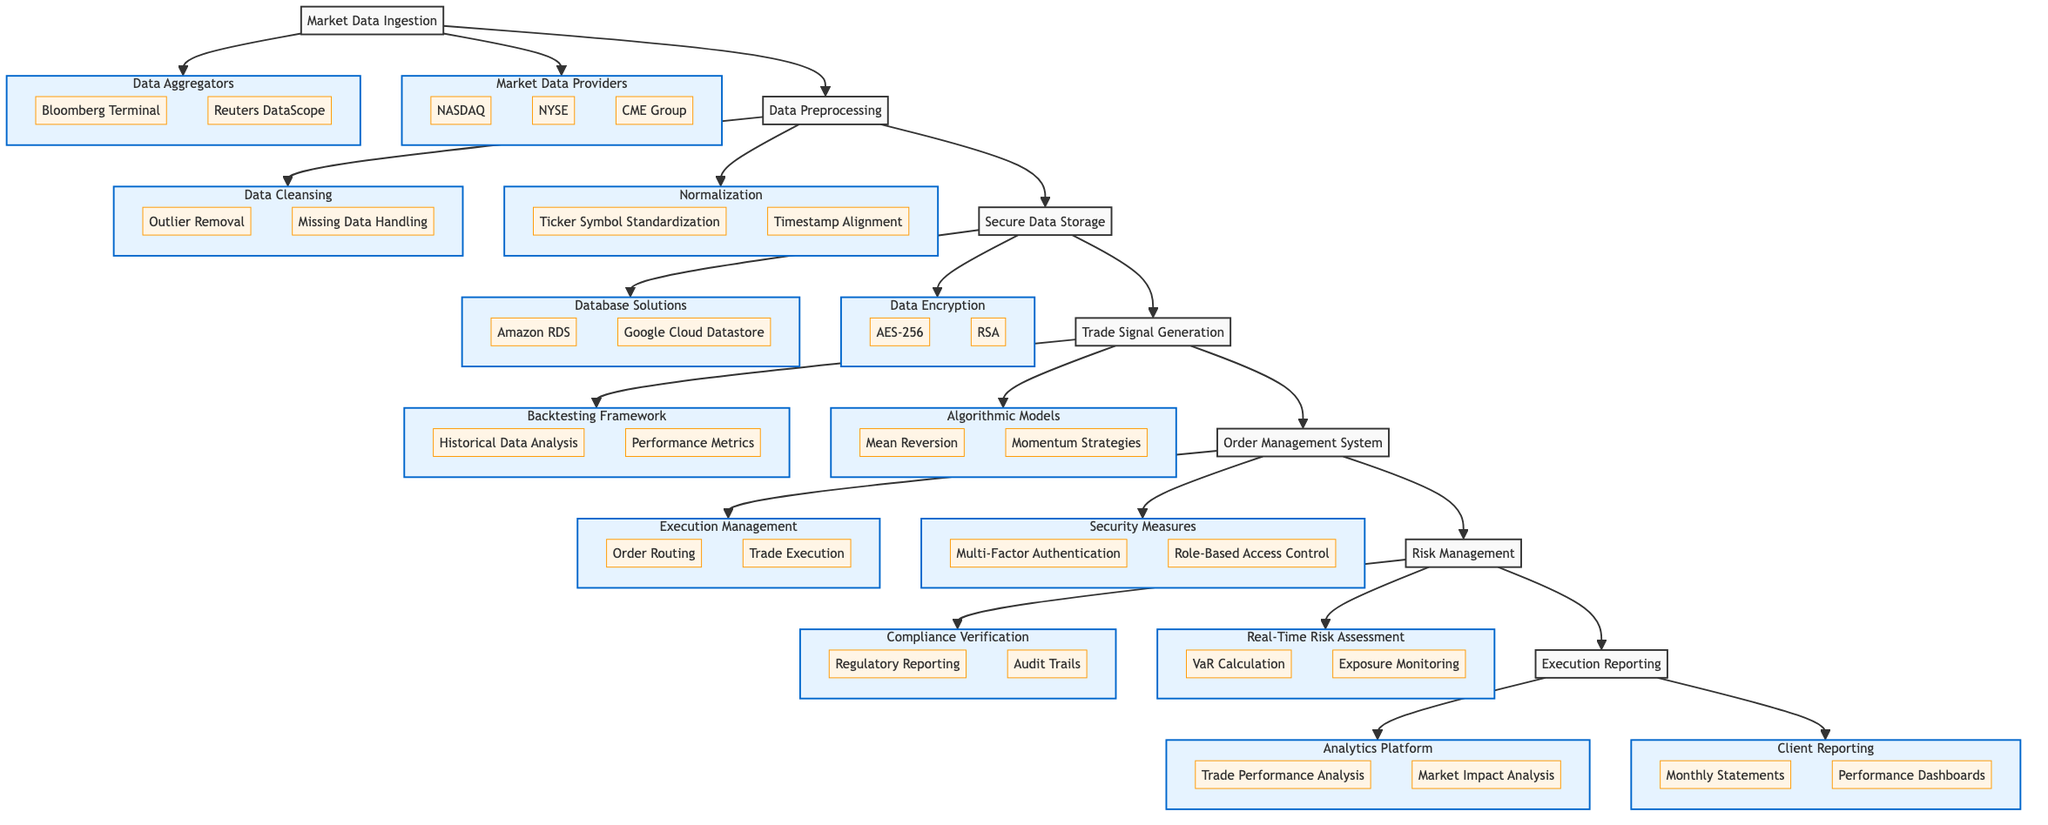What are the two main components of Market Data Ingestion? The diagram shows two components underneath Market Data Ingestion: Market Data Providers and Data Aggregators.
Answer: Market Data Providers, Data Aggregators How many subcomponents are listed under Data Preprocessing? Under Data Preprocessing, there are two main components: Normalization and Data Cleansing. Each of these further has two subcomponents. Thus, there are 4 subcomponents in total.
Answer: 4 What encryption methods are used in Secure Data Storage? The diagram indicates two specific encryption methods in the Secure Data Storage component: AES-256 and RSA.
Answer: AES-256, RSA Which component comes directly before Trade Signal Generation? Following the flow in the diagram, the component that comes directly before Trade Signal Generation is Secure Data Storage.
Answer: Secure Data Storage What is the first security measure listed under Order Management System? The diagram identifies Multi-Factor Authentication as the first security measure under the Order Management System component.
Answer: Multi-Factor Authentication How many components are there after Market Data Ingestion? Looking at the flow after Market Data Ingestion, there are five components in total: Data Preprocessing, Secure Data Storage, Trade Signal Generation, Order Management System, and Risk Management.
Answer: 5 What type of analysis does the Analytics Platform focus on? The Analytics Platform component is primarily focused on two types of analysis: Trade Performance Analysis and Market Impact Analysis.
Answer: Trade Performance Analysis, Market Impact Analysis Which component is responsible for Compliance Verification? The Compliance Verification responsibility is under the Risk Management component as indicated by the diagram.
Answer: Risk Management What is the last main component in the data flow? The last main component in the flowchart is Execution Reporting, as denoted at the end of the flow.
Answer: Execution Reporting 